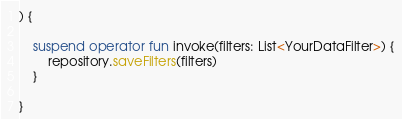Convert code to text. <code><loc_0><loc_0><loc_500><loc_500><_Kotlin_>) {

    suspend operator fun invoke(filters: List<YourDataFilter>) {
        repository.saveFilters(filters)
    }

}</code> 